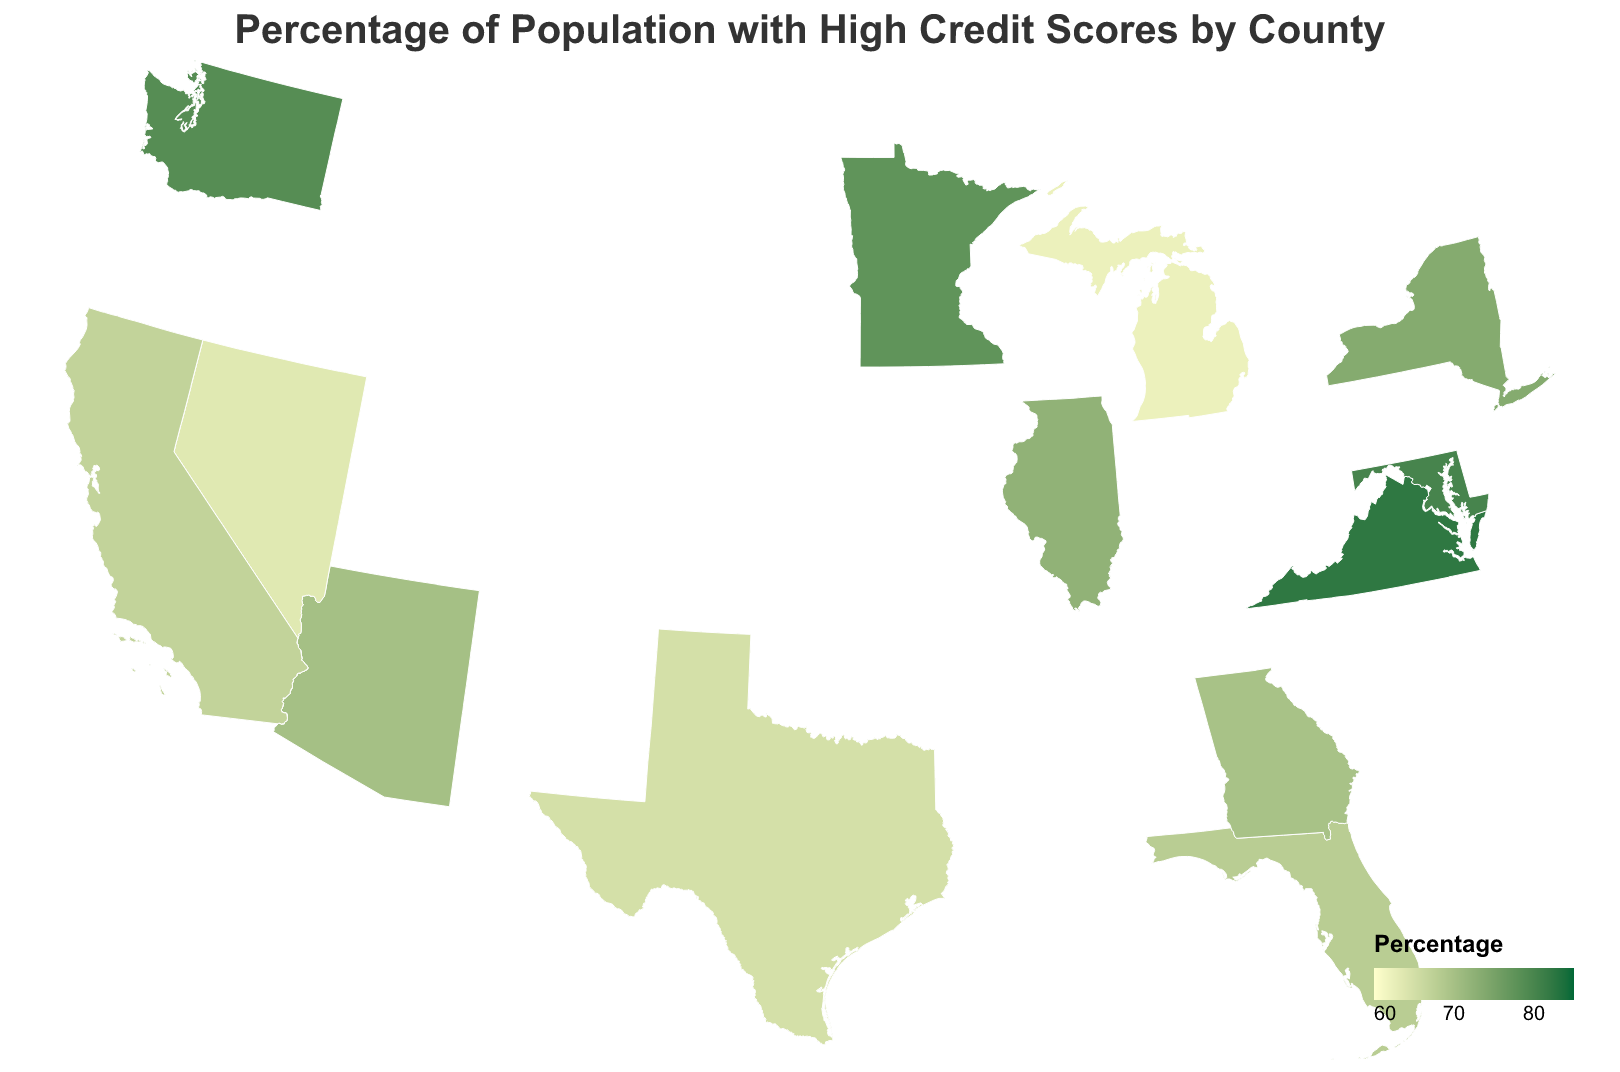Which county has the highest percentage of the population with high credit scores? The figure shows different counties with their respective percentages of the population with high credit scores. By looking at the color gradient and tooltips, we can identify which county has the highest percentage.
Answer: Fairfax, Virginia Which county has the lowest percentage of the population with high credit scores? By examining the color gradient and the tooltips on the figure, we determine which county has the lowest percentage.
Answer: Wayne, Michigan What is the average percentage of the population with high credit scores for the counties in California? The figure provides the percentages for each county in California: Los Angeles (68.5), San Diego (74.8), Orange (76.2), San Bernardino (64.2), and Riverside (66.9). We sum these and divide by the number of counties: (68.5 + 74.8 + 76.2 + 64.2 + 66.9) / 5 = 70.12.
Answer: 70.12 Compare the percentage of high credit scores between King, Washington, and Hennepin, Minnesota. Which one is higher? We look at the figure and compare the percentages of King, Washington (78.6) and Hennepin, Minnesota (77.5). King has a higher percentage.
Answer: King, Washington Which states have more than one county represented in the figure? By looking at the figure, we identify the states with multiple counties: California (Los Angeles, San Diego, Orange, San Bernardino, Riverside), Texas (Harris, Dallas, Bexar), and New York (Queens, Suffolk).
Answer: California, Texas, New York How does the percentage of high credit scores in Montgomery, Maryland compare to Fulton, Georgia? The figure indicates Montgomery, Maryland has 80.1 and Fulton, Georgia has 69.7. By comparing these values, Montgomery has a higher percentage.
Answer: Montgomery, Maryland What is the difference in the percentage of high credit scores between Cook, Illinois, and Clark, Nevada? Cook, Illinois has a high credit score percentage of 72.3, and Clark, Nevada has 63.5. The difference is 72.3 - 63.5 = 8.8.
Answer: 8.8 What is the median percentage of the population with high credit scores among all listed counties? To find the median, we first list all percentages in ascending order: 62.1, 63.5, 64.2, 64.8, 65.7, 66.4, 66.9, 67.9, 68.5, 69.7, 70.1, 71.8, 72.3, 73.6, 74.8, 76.2, 77.5, 78.6, 80.1, 82.3. With 20 values, the median is the average of the 10th and 11th values: (68.5 + 69.7) / 2 = 69.1.
Answer: 69.1 Identify one county in the figure with a high credit score percentage above 75% and below 80%. From the figure, counties such as Orange, California (76.2) and Hennepin, Minnesota (77.5) fit this criterion.
Answer: Orange, California / Hennepin, Minnesota 